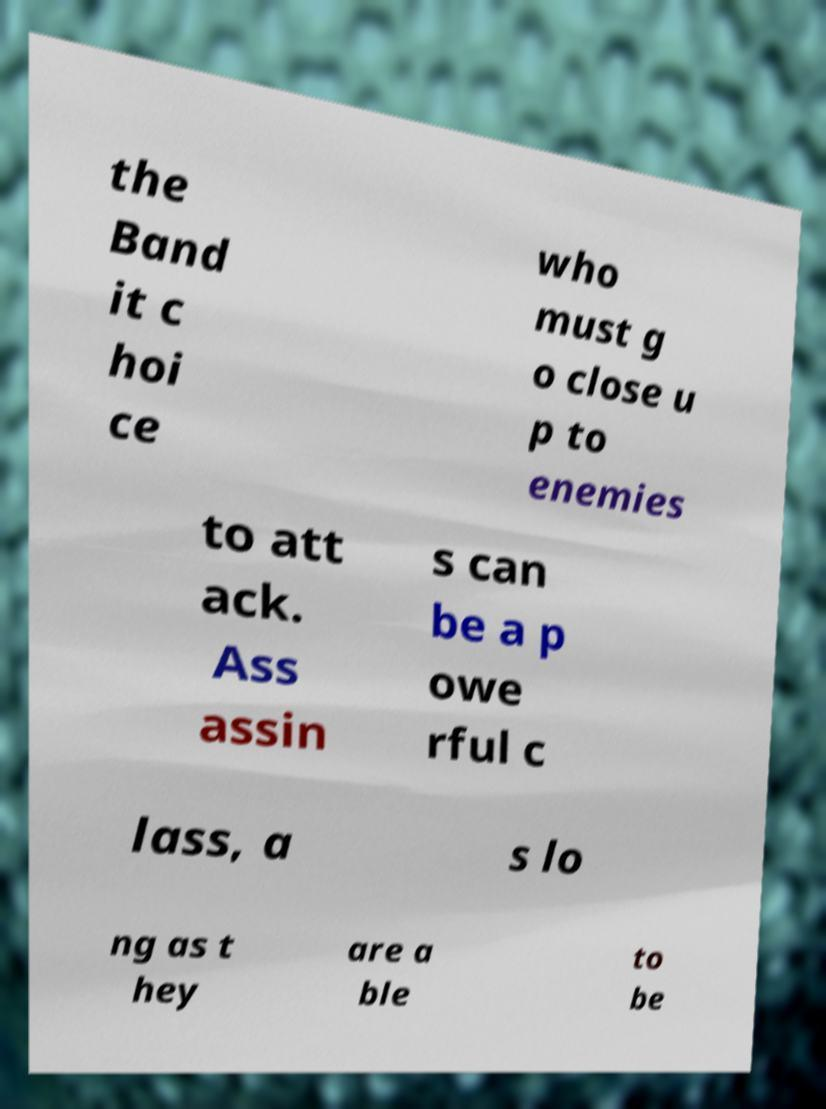Can you accurately transcribe the text from the provided image for me? the Band it c hoi ce who must g o close u p to enemies to att ack. Ass assin s can be a p owe rful c lass, a s lo ng as t hey are a ble to be 